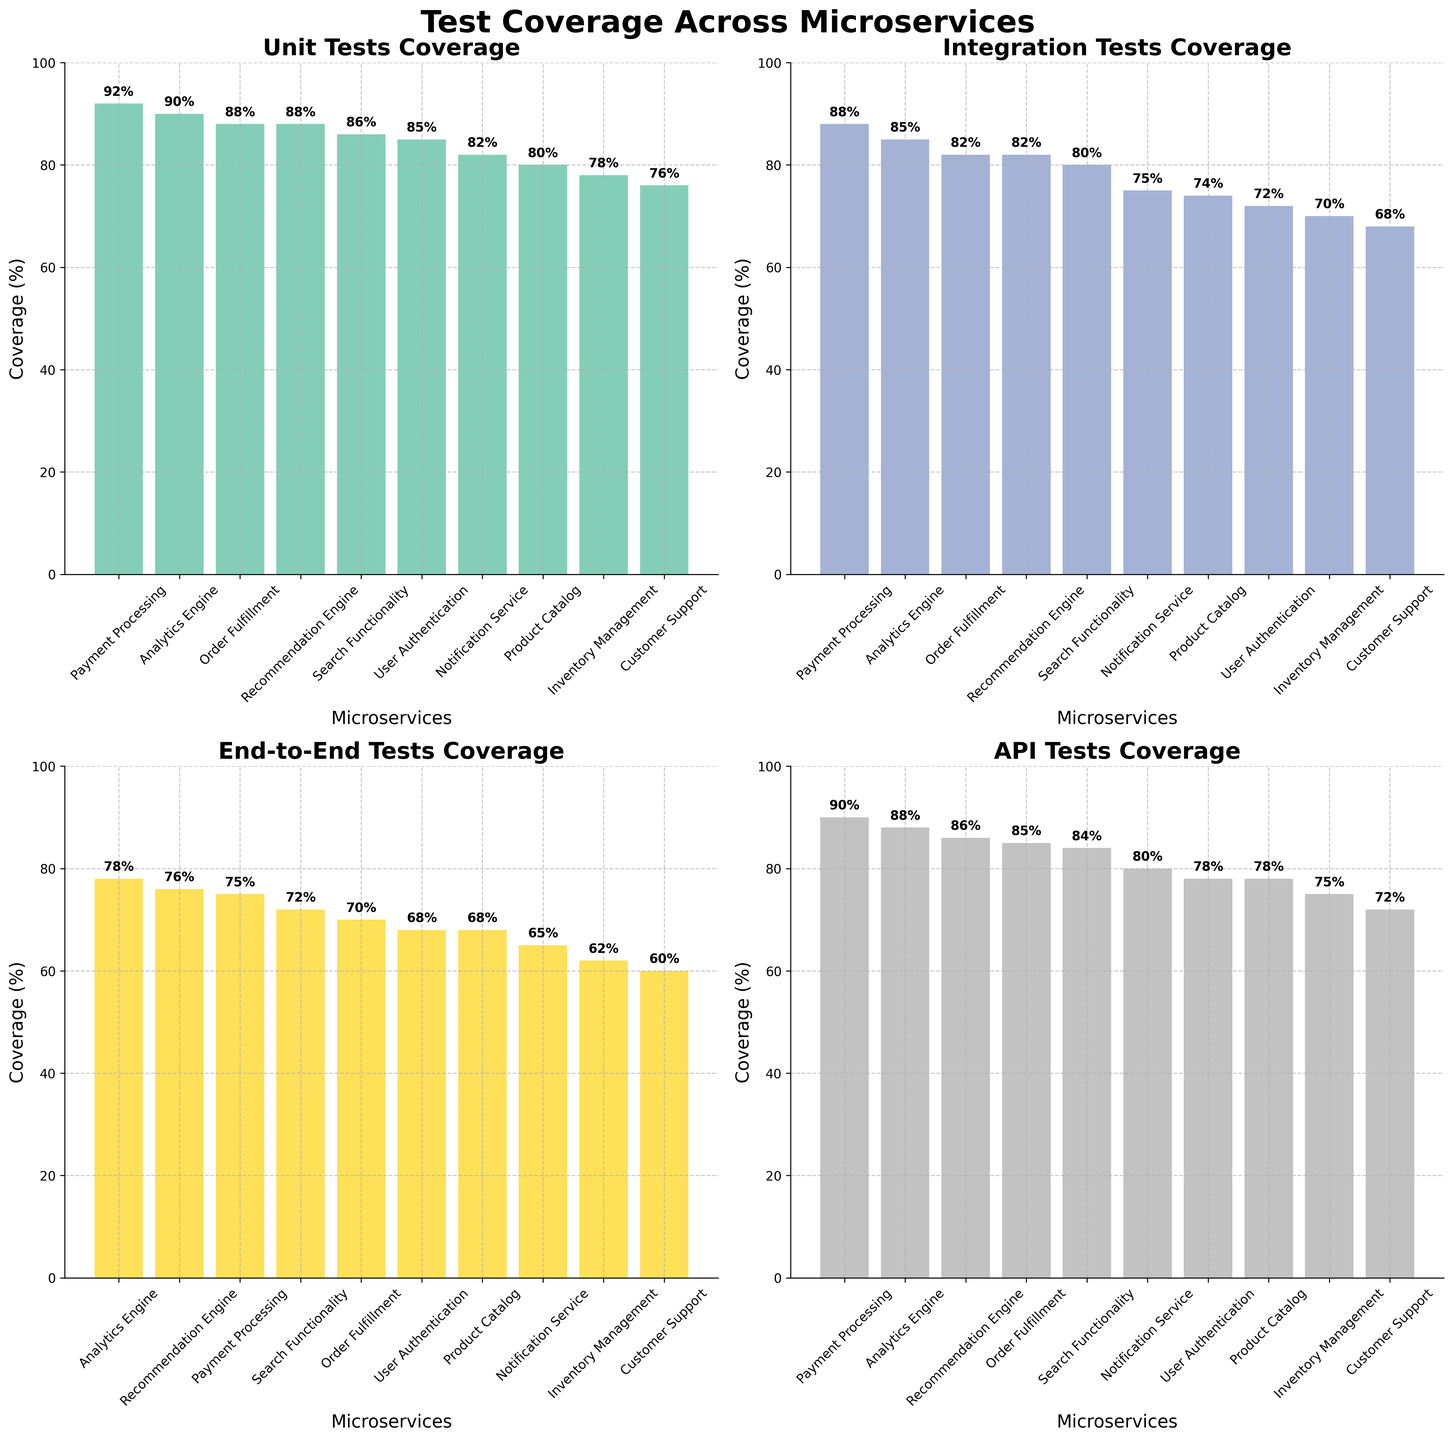what's the title of the figure? The title of the figure is given at the top of the overall plot. It states that the plot covers the test coverage across different microservices.
Answer: Test Coverage Across Microservices Which microservice has the highest unit test coverage? Look at the subplot titled "Unit Tests Coverage" and find the bar with the highest value. This corresponds to the microservice at the top.
Answer: Payment Processing How many microservices have end-to-end test coverage above 70%? In the "End-to-End Tests Coverage" subplot, count the number of bars with values above the 70% mark on the y-axis.
Answer: Three What's the average API test coverage across all microservices? To find the average API test coverage, sum all API test coverage percentages and divide by the number of microservices: (78 + 90 + 75 + 85 + 72 + 88 + 80 + 84 + 78 + 86)/10.
Answer: 81.6 Which microservice has the least integration test coverage, and what is its percentage? In the "Integration Tests Coverage" subplot, find the bar with the smallest value and identify the corresponding microservice and its coverage percentage.
Answer: Customer Support Is the unit test coverage for the Notification Service greater than its integration test coverage? Compare the Unit Tests Coverage bar and the Integration Tests Coverage bar for the Notification Service in their respective subplots.
Answer: No Which two microservices have the closest API test coverage values? Compare the API Test Coverage values for all microservices and identify the microservices with the smallest difference in their percentages.
Answer: Product Catalog and User Authentication How does the test coverage of Order Fulfillment compare across different test types? Locate Order Fulfillment in each subplot and compare the bars representing its test coverage in Unit Tests, Integration Tests, End-to-End Tests, and API Tests.
Answer: Unit: 88%, Integration: 82%, End-to-End: 70%, API: 85% What's the range of integration test coverage across all microservices? Find the minimum and maximum values of the Integration Tests Coverage bars and calculate the range by subtracting the minimum from the maximum.
Answer: 20% Which microservice has the third highest end-to-end test coverage? In the "End-to-End Tests Coverage" subplot, order the bars from highest to lowest and identify the microservice with the third highest value.
Answer: Recommendation Engine 